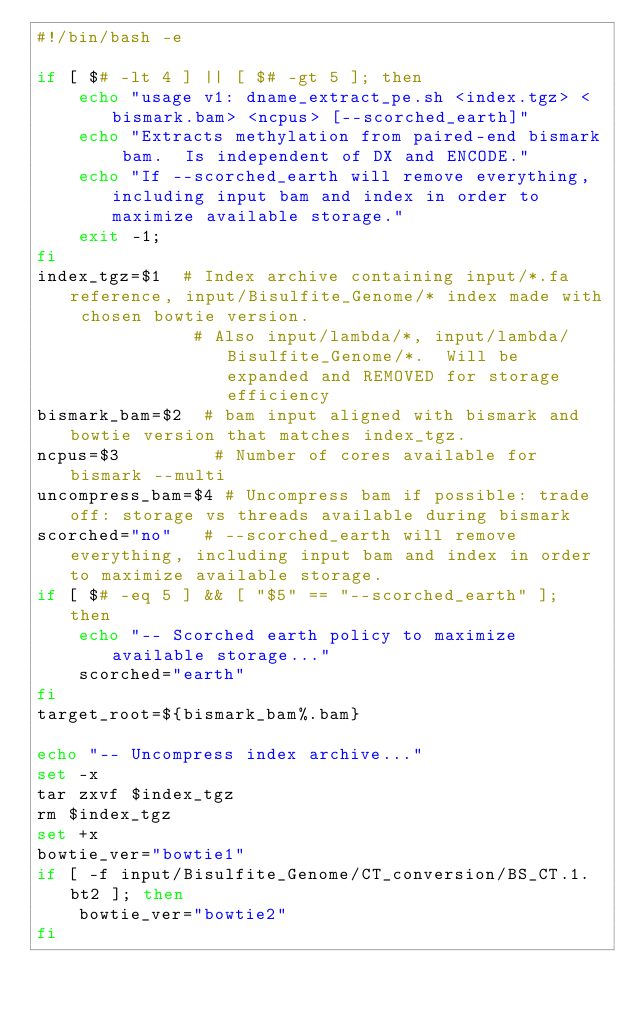Convert code to text. <code><loc_0><loc_0><loc_500><loc_500><_Bash_>#!/bin/bash -e

if [ $# -lt 4 ] || [ $# -gt 5 ]; then
    echo "usage v1: dname_extract_pe.sh <index.tgz> <bismark.bam> <ncpus> [--scorched_earth]"
    echo "Extracts methylation from paired-end bismark bam.  Is independent of DX and ENCODE."
    echo "If --scorched_earth will remove everything, including input bam and index in order to maximize available storage."
    exit -1; 
fi
index_tgz=$1  # Index archive containing input/*.fa reference, input/Bisulfite_Genome/* index made with chosen bowtie version.
               # Also input/lambda/*, input/lambda/Bisulfite_Genome/*.  Will be expanded and REMOVED for storage efficiency
bismark_bam=$2  # bam input aligned with bismark and bowtie version that matches index_tgz.
ncpus=$3         # Number of cores available for bismark --multi
uncompress_bam=$4 # Uncompress bam if possible: trade off: storage vs threads available during bismark
scorched="no"   # --scorched_earth will remove everything, including input bam and index in order to maximize available storage.
if [ $# -eq 5 ] && [ "$5" == "--scorched_earth" ]; then
    echo "-- Scorched earth policy to maximize available storage..."
    scorched="earth"
fi
target_root=${bismark_bam%.bam}

echo "-- Uncompress index archive..."
set -x
tar zxvf $index_tgz
rm $index_tgz
set +x
bowtie_ver="bowtie1"
if [ -f input/Bisulfite_Genome/CT_conversion/BS_CT.1.bt2 ]; then
    bowtie_ver="bowtie2"
fi
</code> 